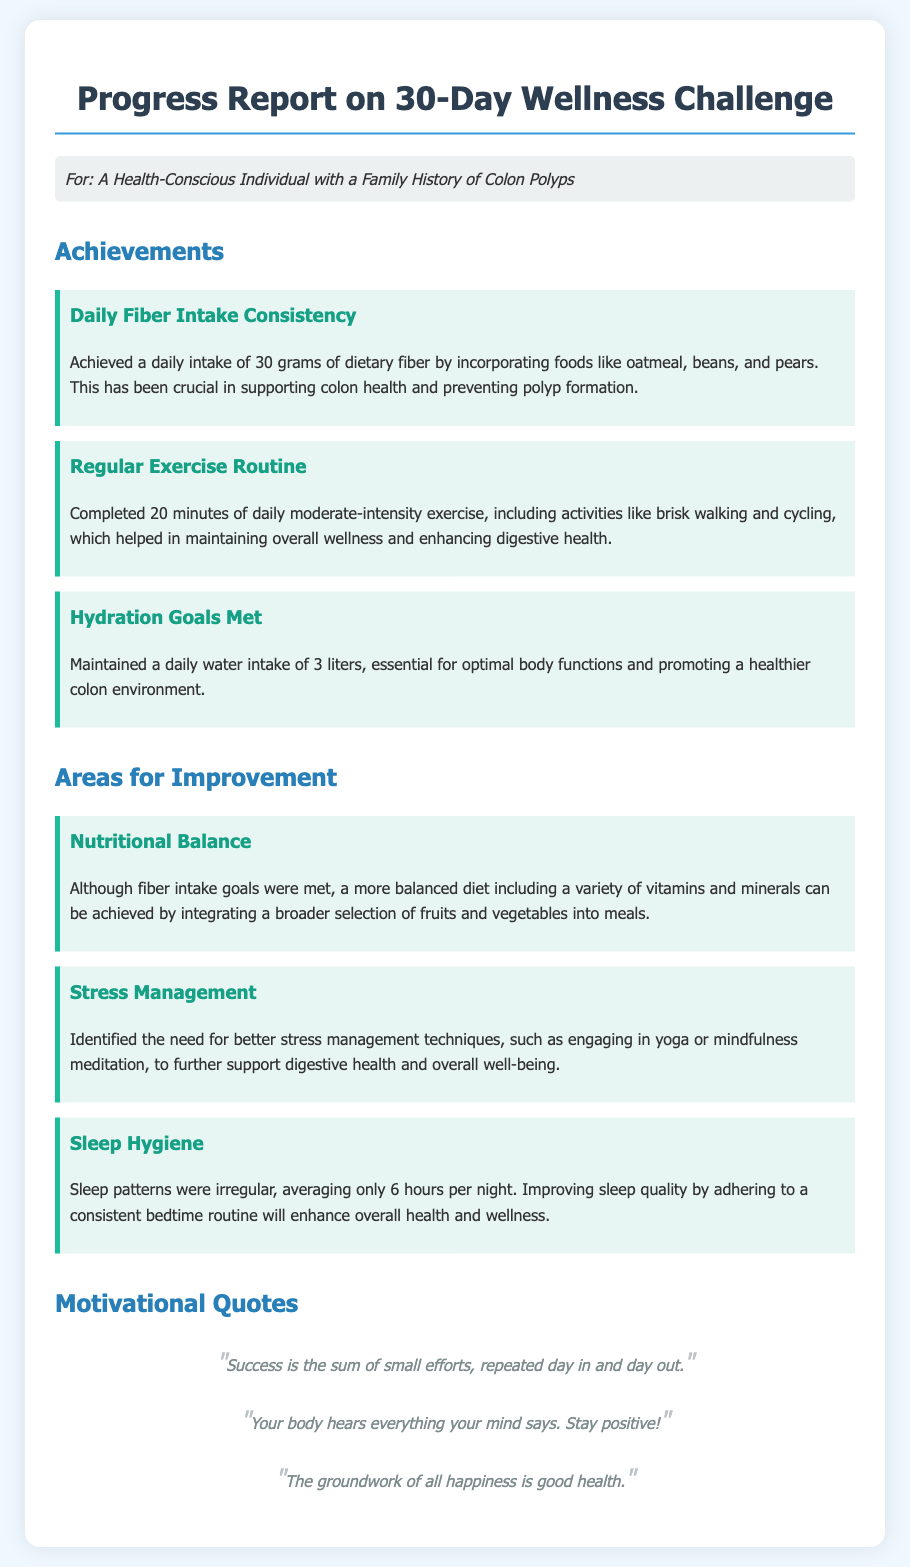What was the daily fiber intake achieved? The document states that a daily intake of 30 grams of dietary fiber was achieved.
Answer: 30 grams What is one of the activities included in the regular exercise routine? The document mentions brisk walking and cycling as part of the exercise routine.
Answer: Brisk walking How much water was maintained daily? The report indicates a daily water intake of 3 liters.
Answer: 3 liters What aspect of health was identified for improvement related to sleep? The document notes that sleep patterns were irregular and averaged only 6 hours per night.
Answer: 6 hours What is the first motivational quote mentioned? The first motivational quote given in the document is about small efforts leading to success.
Answer: Success is the sum of small efforts, repeated day in and day out Why is a balanced diet recommended? The document suggests incorporating a wider variety of fruits and vegetables for a more balanced diet.
Answer: To achieve a more balanced diet What stress management techniques were mentioned for improvement? The report highlighted engaging in yoga or mindfulness meditation as techniques for stress management.
Answer: Yoga or mindfulness meditation What color is used for the header background? The document describes the background color of the header as light gray.
Answer: Light gray 